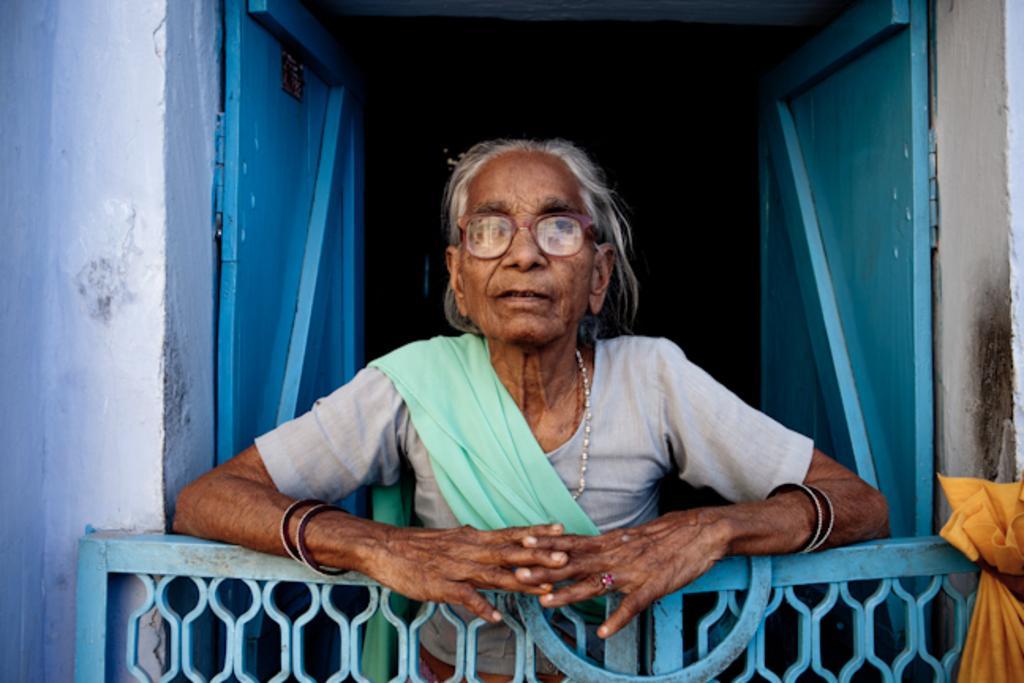How would you summarize this image in a sentence or two? In the center of the image we can see a person is standing. At the bottom of the image, we can see a gate and one cloth. In the background there is a wall and a door. 